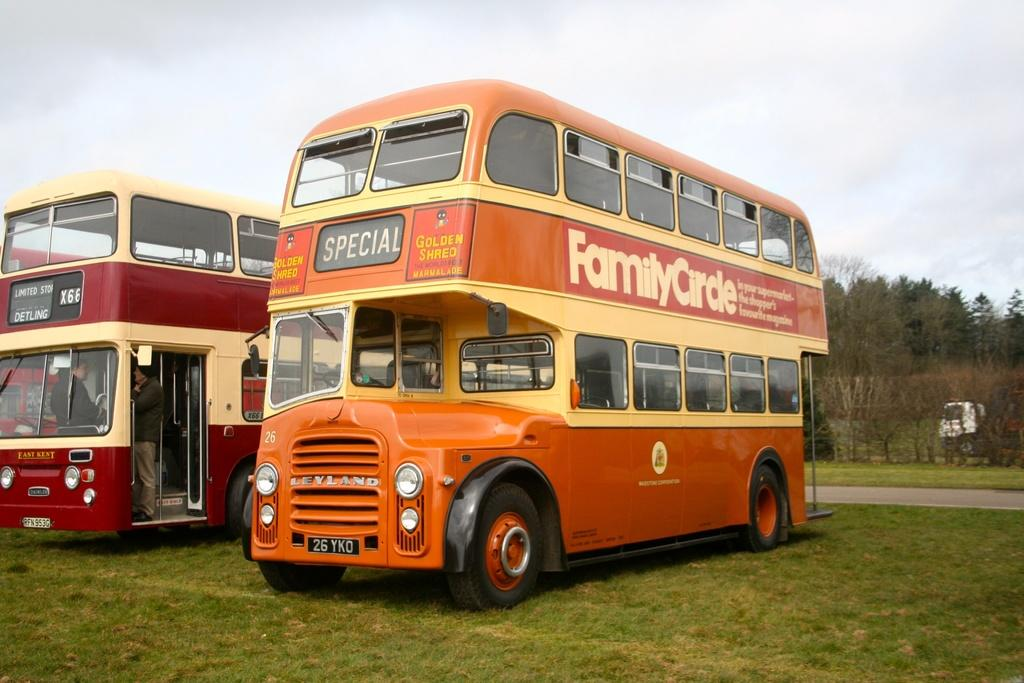<image>
Describe the image concisely. a bus that says 'special' on the front of it in digital letters 